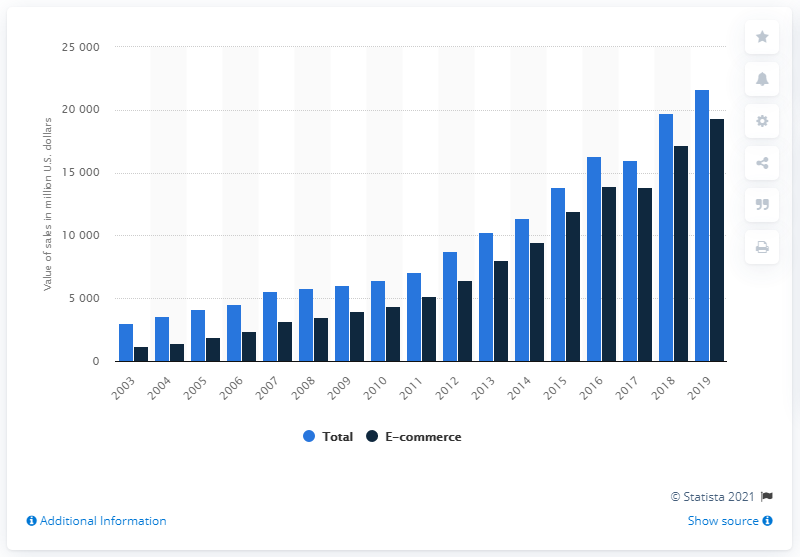Highlight a few significant elements in this photo. The sales figures for sporting goods of electronic shopping and mail-order houses began in 2003. 